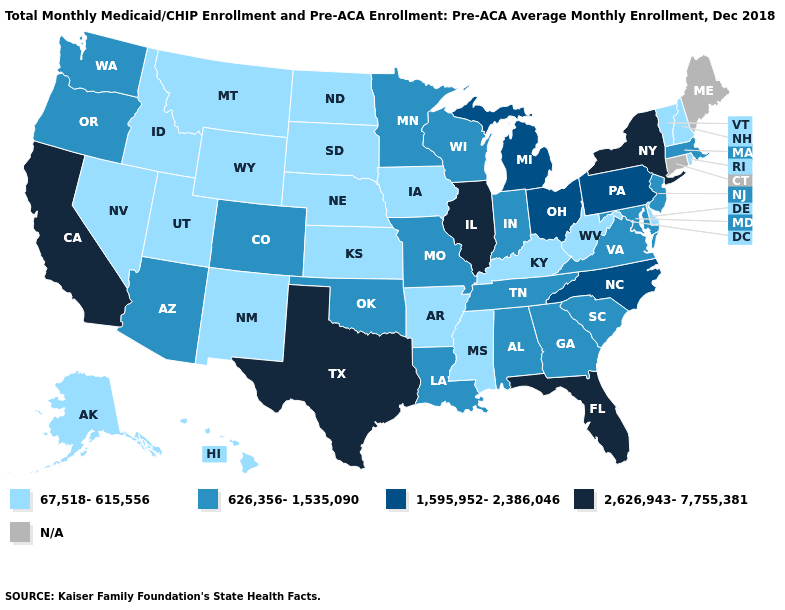What is the value of Kentucky?
Write a very short answer. 67,518-615,556. What is the value of New Mexico?
Keep it brief. 67,518-615,556. Does the first symbol in the legend represent the smallest category?
Short answer required. Yes. Does Illinois have the lowest value in the USA?
Give a very brief answer. No. Does California have the highest value in the West?
Short answer required. Yes. What is the value of Florida?
Be succinct. 2,626,943-7,755,381. Name the states that have a value in the range 67,518-615,556?
Keep it brief. Alaska, Arkansas, Delaware, Hawaii, Idaho, Iowa, Kansas, Kentucky, Mississippi, Montana, Nebraska, Nevada, New Hampshire, New Mexico, North Dakota, Rhode Island, South Dakota, Utah, Vermont, West Virginia, Wyoming. Which states have the highest value in the USA?
Write a very short answer. California, Florida, Illinois, New York, Texas. Does the first symbol in the legend represent the smallest category?
Give a very brief answer. Yes. Does Vermont have the highest value in the Northeast?
Write a very short answer. No. What is the highest value in states that border Minnesota?
Keep it brief. 626,356-1,535,090. Name the states that have a value in the range 67,518-615,556?
Quick response, please. Alaska, Arkansas, Delaware, Hawaii, Idaho, Iowa, Kansas, Kentucky, Mississippi, Montana, Nebraska, Nevada, New Hampshire, New Mexico, North Dakota, Rhode Island, South Dakota, Utah, Vermont, West Virginia, Wyoming. Among the states that border Rhode Island , which have the highest value?
Quick response, please. Massachusetts. Name the states that have a value in the range 626,356-1,535,090?
Keep it brief. Alabama, Arizona, Colorado, Georgia, Indiana, Louisiana, Maryland, Massachusetts, Minnesota, Missouri, New Jersey, Oklahoma, Oregon, South Carolina, Tennessee, Virginia, Washington, Wisconsin. Does the first symbol in the legend represent the smallest category?
Quick response, please. Yes. 